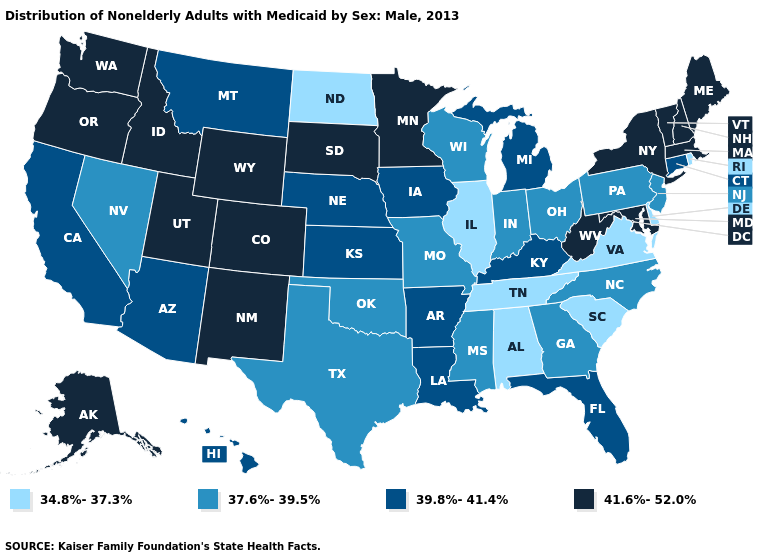Name the states that have a value in the range 41.6%-52.0%?
Give a very brief answer. Alaska, Colorado, Idaho, Maine, Maryland, Massachusetts, Minnesota, New Hampshire, New Mexico, New York, Oregon, South Dakota, Utah, Vermont, Washington, West Virginia, Wyoming. Which states have the highest value in the USA?
Short answer required. Alaska, Colorado, Idaho, Maine, Maryland, Massachusetts, Minnesota, New Hampshire, New Mexico, New York, Oregon, South Dakota, Utah, Vermont, Washington, West Virginia, Wyoming. Name the states that have a value in the range 39.8%-41.4%?
Be succinct. Arizona, Arkansas, California, Connecticut, Florida, Hawaii, Iowa, Kansas, Kentucky, Louisiana, Michigan, Montana, Nebraska. What is the value of Arizona?
Short answer required. 39.8%-41.4%. Name the states that have a value in the range 41.6%-52.0%?
Write a very short answer. Alaska, Colorado, Idaho, Maine, Maryland, Massachusetts, Minnesota, New Hampshire, New Mexico, New York, Oregon, South Dakota, Utah, Vermont, Washington, West Virginia, Wyoming. Does Vermont have a higher value than Nebraska?
Concise answer only. Yes. What is the value of New Mexico?
Short answer required. 41.6%-52.0%. What is the value of California?
Quick response, please. 39.8%-41.4%. What is the value of Oklahoma?
Write a very short answer. 37.6%-39.5%. What is the value of Texas?
Write a very short answer. 37.6%-39.5%. Name the states that have a value in the range 39.8%-41.4%?
Write a very short answer. Arizona, Arkansas, California, Connecticut, Florida, Hawaii, Iowa, Kansas, Kentucky, Louisiana, Michigan, Montana, Nebraska. Which states hav the highest value in the Northeast?
Answer briefly. Maine, Massachusetts, New Hampshire, New York, Vermont. Does Alaska have the highest value in the USA?
Give a very brief answer. Yes. 